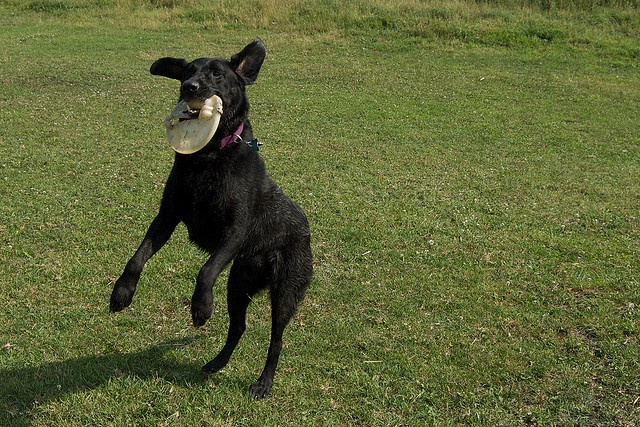Describe the objects in this image and their specific colors. I can see dog in darkgreen, black, gray, and olive tones and frisbee in darkgreen, gray, and black tones in this image. 